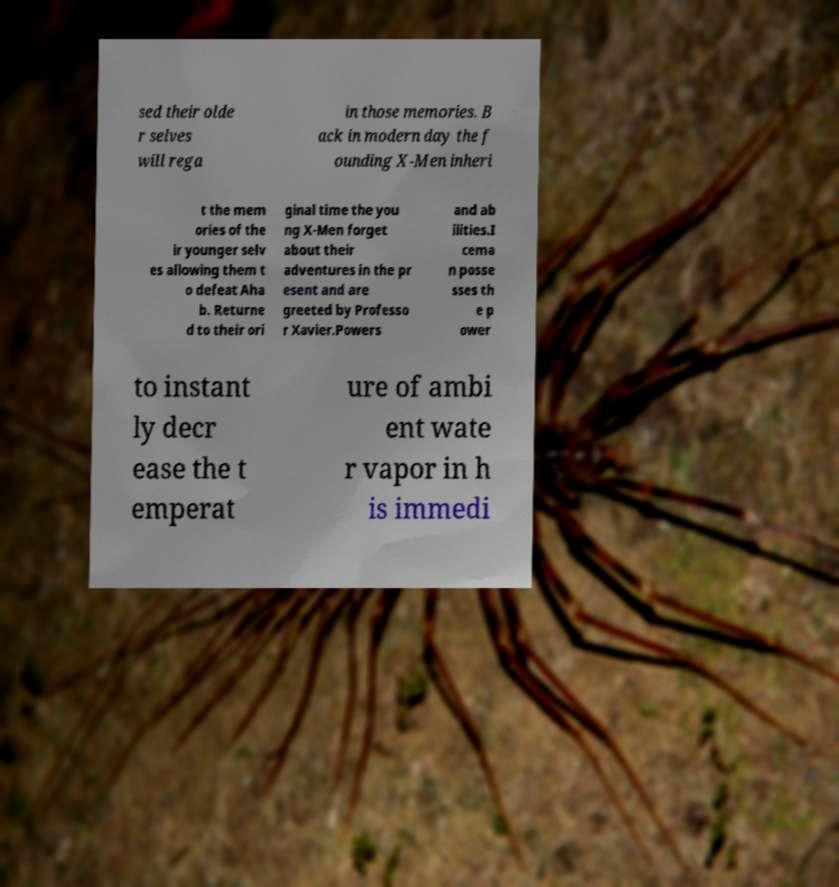I need the written content from this picture converted into text. Can you do that? sed their olde r selves will rega in those memories. B ack in modern day the f ounding X-Men inheri t the mem ories of the ir younger selv es allowing them t o defeat Aha b. Returne d to their ori ginal time the you ng X-Men forget about their adventures in the pr esent and are greeted by Professo r Xavier.Powers and ab ilities.I cema n posse sses th e p ower to instant ly decr ease the t emperat ure of ambi ent wate r vapor in h is immedi 